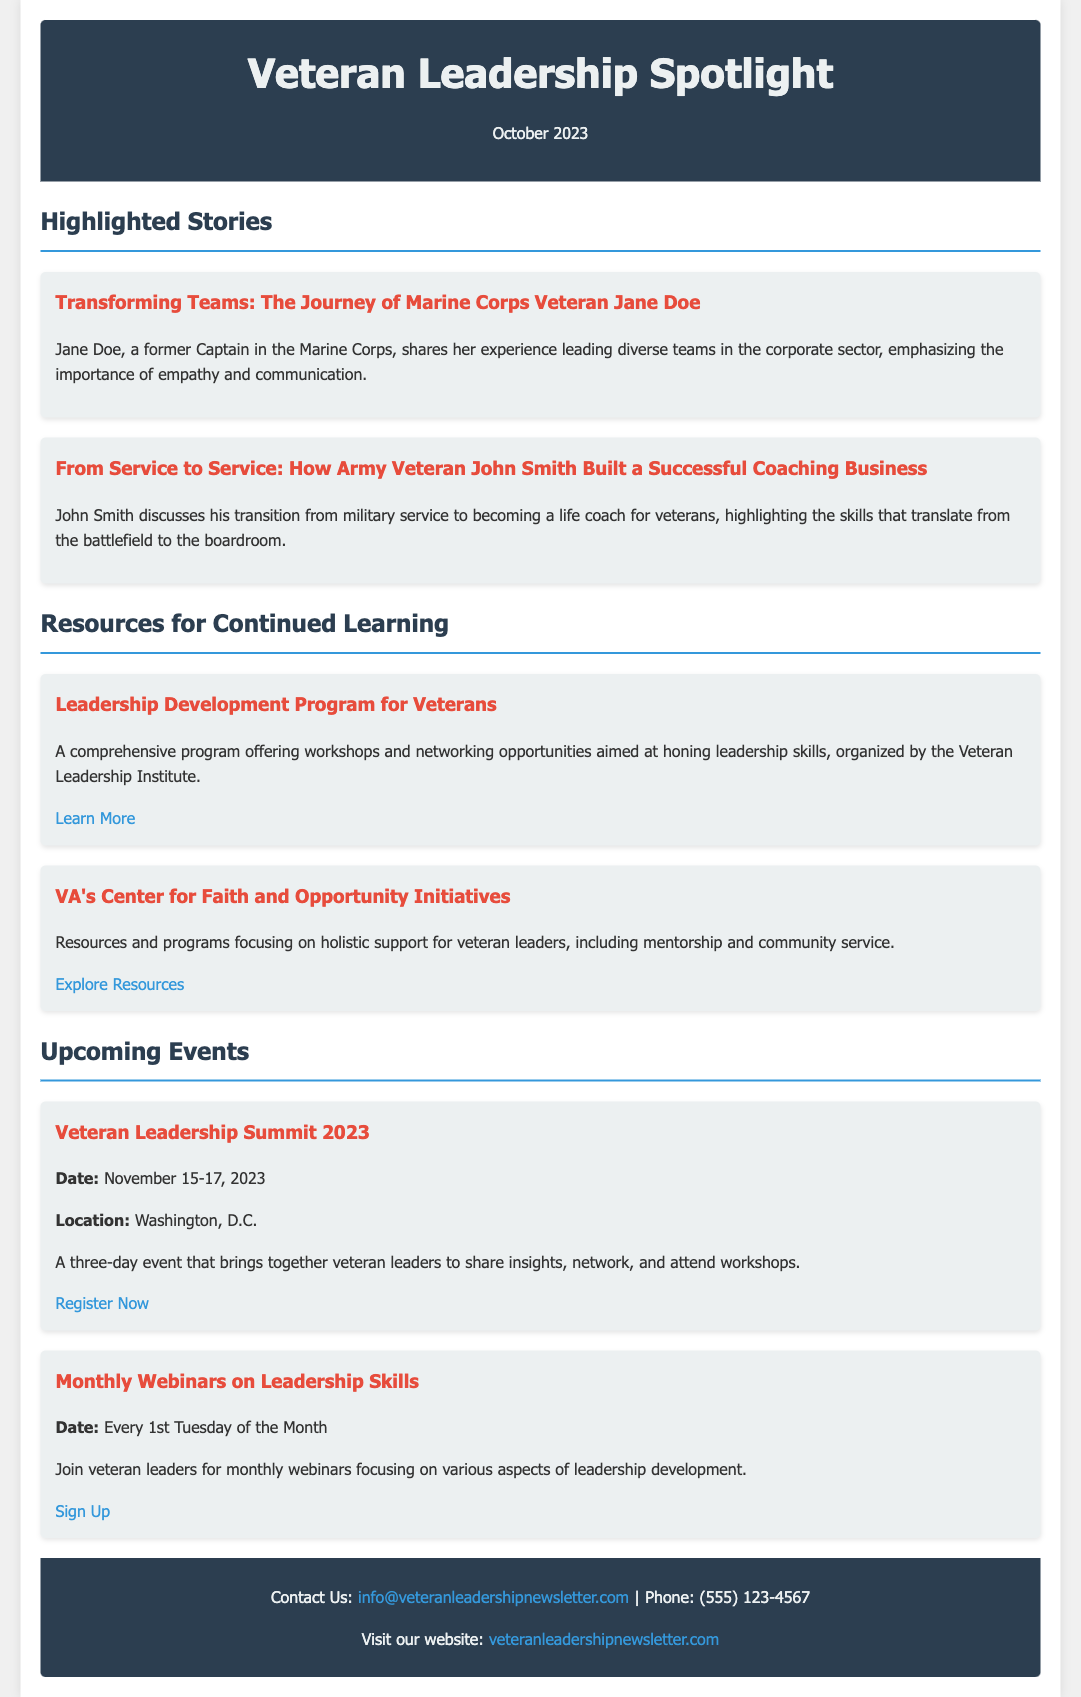What is the title of the newsletter? The title of the newsletter is prominently mentioned at the top of the document as "Veteran Leadership Spotlight."
Answer: Veteran Leadership Spotlight When is the publication date of the newsletter? The publication date is stated in the header section, indicating the month and year of the newsletter as October 2023.
Answer: October 2023 Who is featured in the highlighted story about transforming teams? The highlighted story mentions Jane Doe, a Marine Corps veteran, as the individual sharing her experiences.
Answer: Jane Doe What are the two resources listed for continued learning? The resources provided focus on leadership development and holistic support for veteran leaders as described in the resource section.
Answer: Leadership Development Program for Veterans, VA's Center for Faith and Opportunity Initiatives What is the date of the Veteran Leadership Summit 2023? The event section specifies the date of the summit, which is a three-day event happening in the future.
Answer: November 15-17, 2023 How often do the monthly webinars occur? The event section indicates that the webinars are scheduled to take place regularly on a specific day of the month.
Answer: Every 1st Tuesday of the Month What is the purpose of the Veteran Leadership Newsletter? The purpose can be inferred from the description, which highlights success stories, resources, and events specifically for veteran leaders.
Answer: Highlighting success stories, resources, and events What type of publication is the Veteran Leadership Spotlight? The document describes the nature of the publication as a visually appealing monthly publication targeting a specific audience.
Answer: Monthly publication 